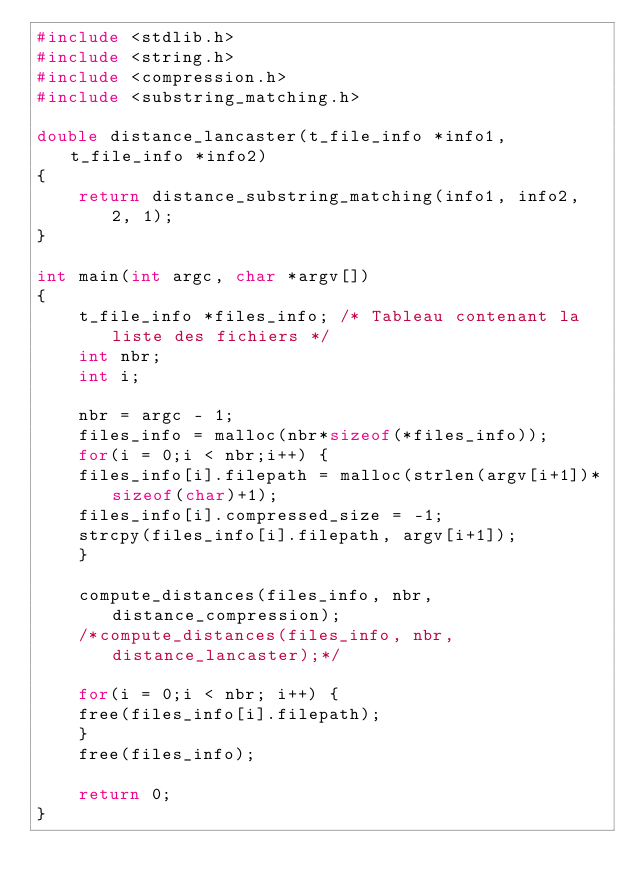<code> <loc_0><loc_0><loc_500><loc_500><_C_>#include <stdlib.h>
#include <string.h>
#include <compression.h>
#include <substring_matching.h>

double distance_lancaster(t_file_info *info1, t_file_info *info2)
{
    return distance_substring_matching(info1, info2, 2, 1);
}

int main(int argc, char *argv[])
{
    t_file_info *files_info; /* Tableau contenant la liste des fichiers */
    int nbr;
    int i;

    nbr = argc - 1;
    files_info = malloc(nbr*sizeof(*files_info));
    for(i = 0;i < nbr;i++) {
	files_info[i].filepath = malloc(strlen(argv[i+1])*sizeof(char)+1);
	files_info[i].compressed_size = -1;
	strcpy(files_info[i].filepath, argv[i+1]);
    }

    compute_distances(files_info, nbr, distance_compression);
    /*compute_distances(files_info, nbr, distance_lancaster);*/

    for(i = 0;i < nbr; i++) {
	free(files_info[i].filepath);
    }
    free(files_info);

    return 0;
}
</code> 